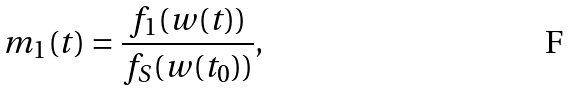Convert formula to latex. <formula><loc_0><loc_0><loc_500><loc_500>m _ { 1 } ( t ) = \frac { f _ { 1 } ( w ( t ) ) } { f _ { S } ( w ( t _ { 0 } ) ) } ,</formula> 